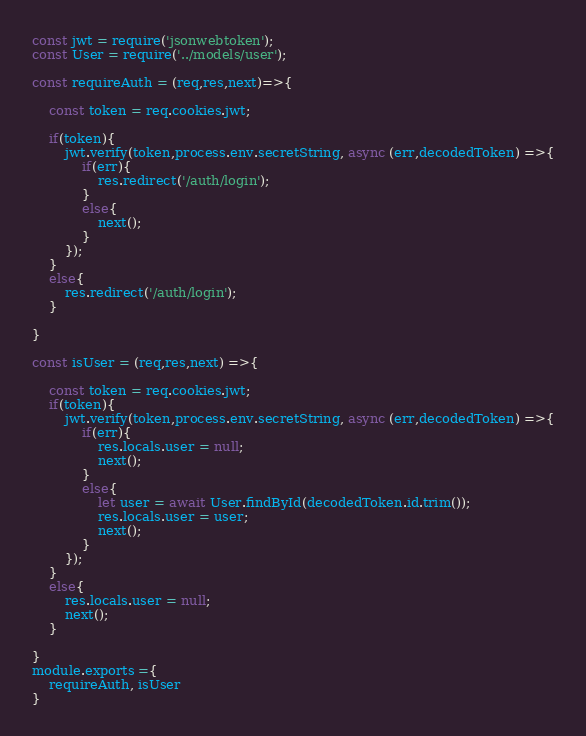<code> <loc_0><loc_0><loc_500><loc_500><_JavaScript_>const jwt = require('jsonwebtoken');
const User = require('../models/user');

const requireAuth = (req,res,next)=>{

    const token = req.cookies.jwt;

    if(token){
        jwt.verify(token,process.env.secretString, async (err,decodedToken) =>{
            if(err){
                res.redirect('/auth/login');
            }
            else{
                next();
            }
        });   
    }
    else{
        res.redirect('/auth/login');
    }

}

const isUser = (req,res,next) =>{

    const token = req.cookies.jwt;
    if(token){
        jwt.verify(token,process.env.secretString, async (err,decodedToken) =>{
            if(err){
                res.locals.user = null;
                next();
            }
            else{
                let user = await User.findById(decodedToken.id.trim());
                res.locals.user = user;
                next();
            }
        });   
    }
    else{
        res.locals.user = null;
        next();
    }

}
module.exports ={
    requireAuth, isUser
}</code> 